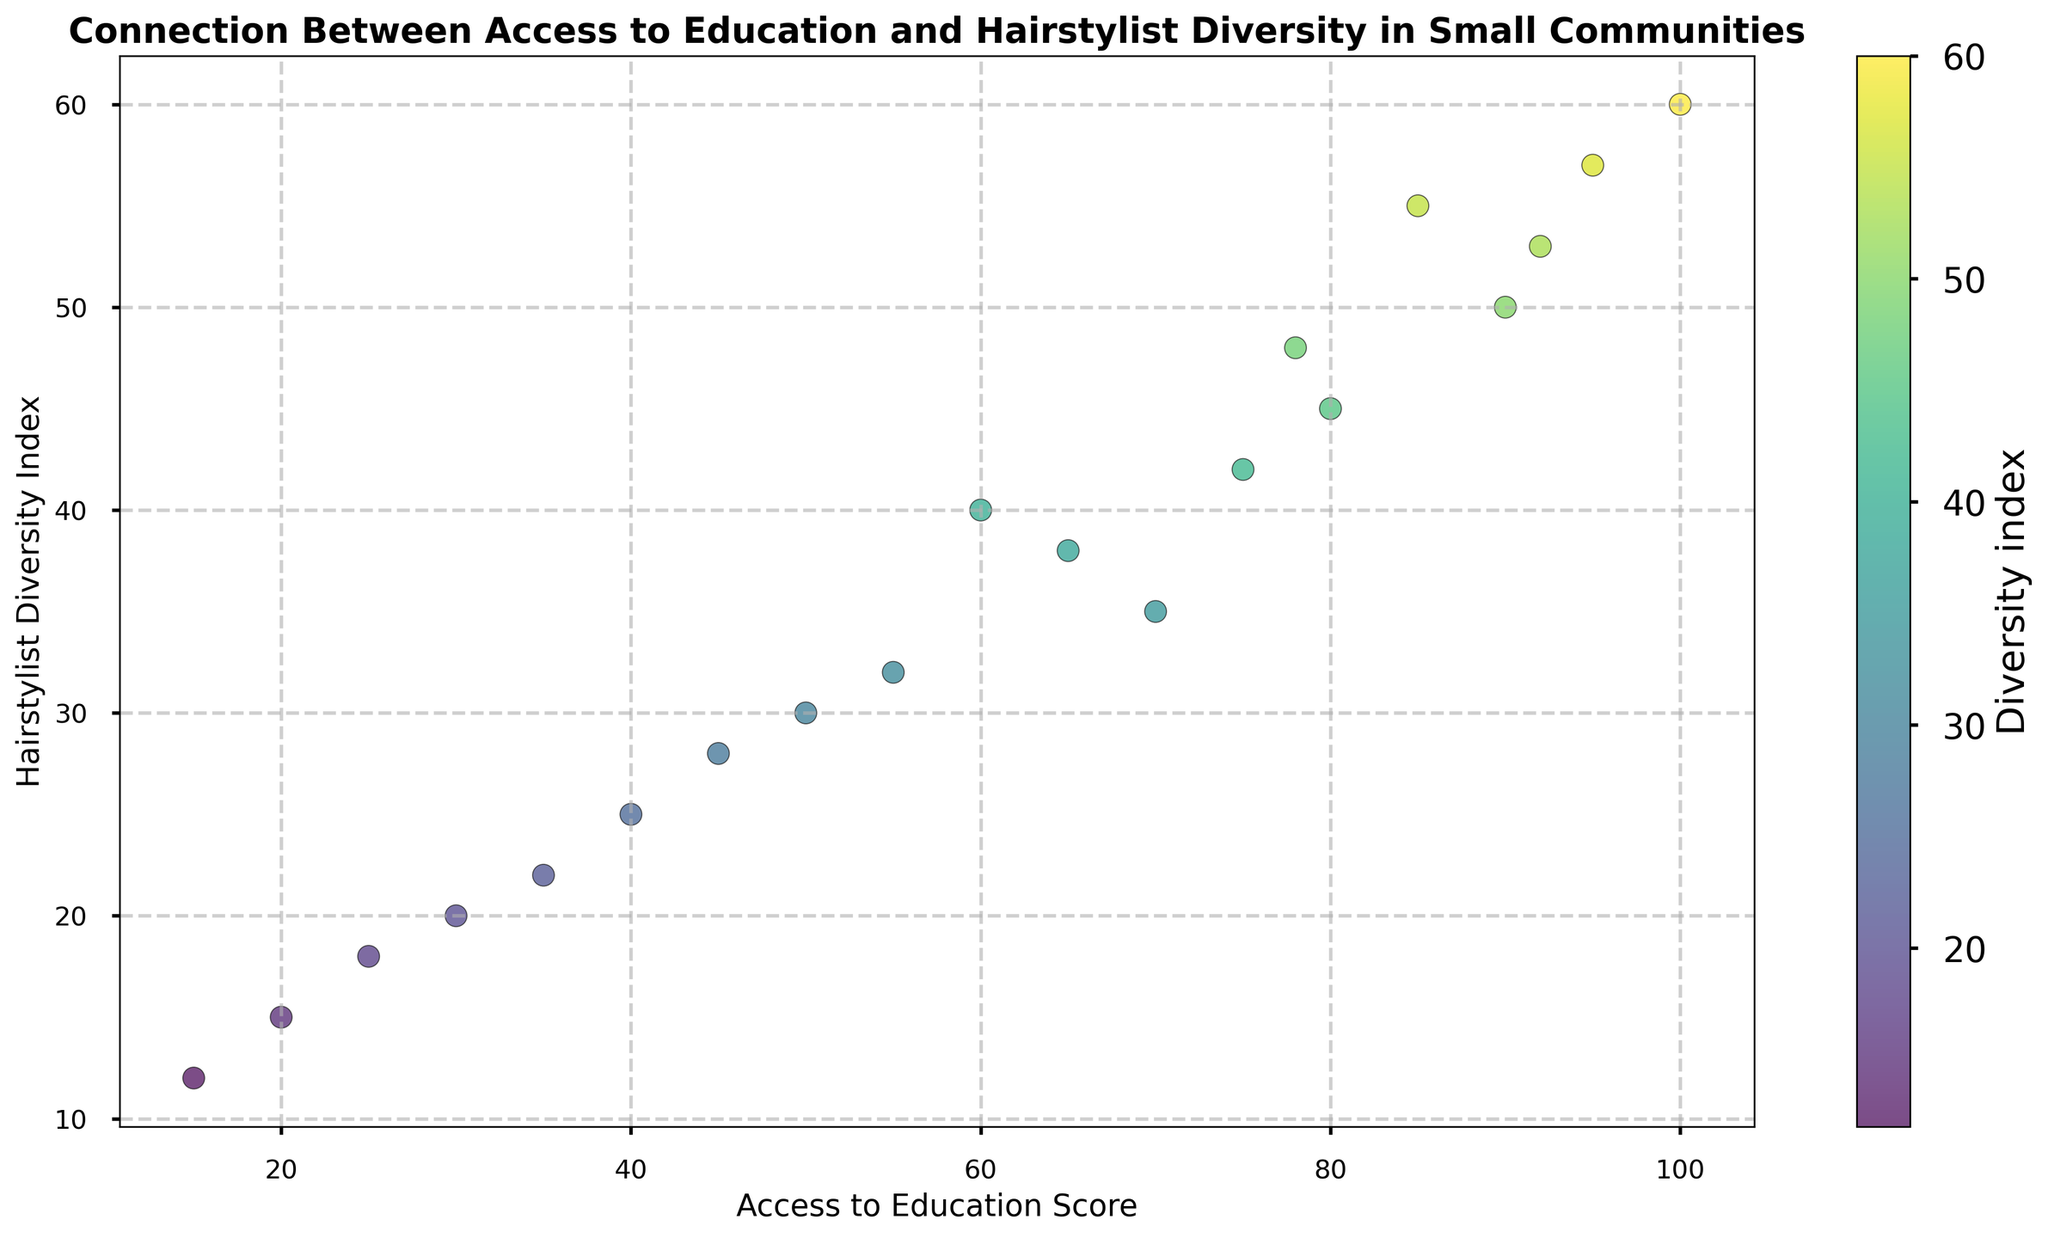Which community has the highest diversity of hairstylists? Community H has the highest diversity index of 60.
Answer: Community H What is the relationship between access to education and hairstylist diversity? By observing the scatter plot, it's evident that communities with higher access to education scores tend to have higher hairstylist diversity indices.
Answer: Positive correlation Which communities have an access to education score greater than 70 but a diversity index less than 50? Community T has an access to education score of 78 and a diversity index of 48.
Answer: Community T What is the average diversity index for communities with an access to education score less than 50? Communities with scores less than 50 are B, D, G, I, O, P, Q, R. Summing their diversity indices (30+20+15+25+28+18+22+12) gives 170, and there are 8 communities. So, 170/8 = 21.25.
Answer: 21.25 Which community has the closest diversity index to the community with the highest access to education? Community H has the highest access score of 100 with a diversity index of 60. The closest diversity index to 60 is 57 from Community N.
Answer: Community N Which communities have a diversity index lower than the median for all communities? To find the median: list diversity indices (12, 15, 18, 20, 22, 25, 28, 30, 32, 35, 38, 40, 42, 45, 48, 50, 53, 55, 57, 60). Median (middle value) is 36. Communities with indices < 36 are A, B, D, G, I, K, O, P, Q, R.
Answer: A, B, D, G, I, K, O, P, Q, R How does the diversity within the community with the lowest access to education compare to the median diversity? Community R has the lowest access score (15) and a diversity index of 12. Median diversity is 36, so 12 is much lower than 36.
Answer: Much lower What is the access to education score for a community with a diversity index twice that of Community Q? Community Q has a diversity index of 22. Twice that is 44. Community with diversity closest to 44 is F (score 40).
Answer: 60 (Community F) Is there a community with an access score and diversity index both above the median values for their respective categories? Medians: Education (Access) 65, Diversity 36. Communities above both medians are C, E, H, J, N, S, T.
Answer: C, E, H, J, N, S, T Which community shows the largest difference in values between access to education and hairstylist diversity? Look for the largest gap in the chart. Community H has access of 100 and diversity of 60, difference is 40. No larger gaps seen.
Answer: Community H 